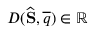<formula> <loc_0><loc_0><loc_500><loc_500>D ( \widehat { S } , \overline { q } ) \in \mathbb { R }</formula> 